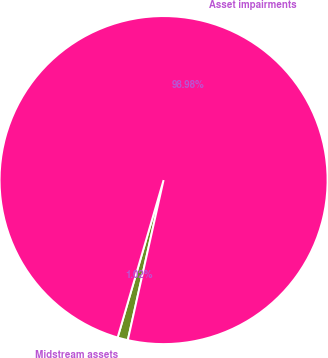<chart> <loc_0><loc_0><loc_500><loc_500><pie_chart><fcel>Midstream assets<fcel>Asset impairments<nl><fcel>1.02%<fcel>98.98%<nl></chart> 